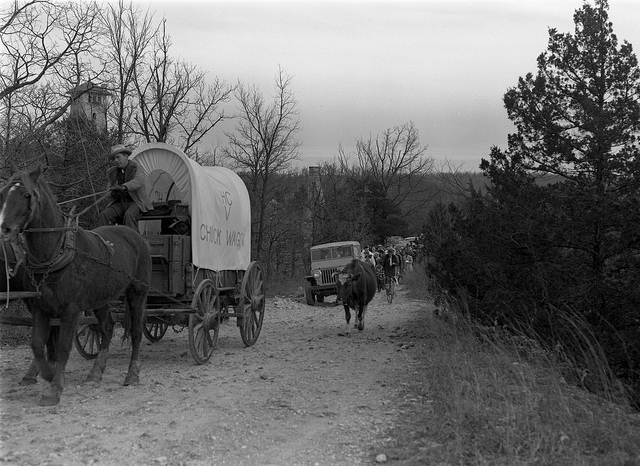<image>What is the animal with the stripes? It is ambiguous what the animal with the stripes is. It could be a horse, a zebra, or there may be no such animal in the image. Why is the horse on the ground? It is unknown why the horse is on the ground. It is not clear from the image. What is the animal with the stripes? I am not sure what animal has stripes. It can be a cow, zebra or horse. Why is the horse on the ground? It is ambiguous why the horse is on the ground. It can be walking or pulling a wagon. 